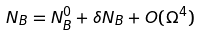Convert formula to latex. <formula><loc_0><loc_0><loc_500><loc_500>N _ { B } = N _ { B } ^ { 0 } + \delta N _ { B } + O ( \Omega ^ { 4 } )</formula> 